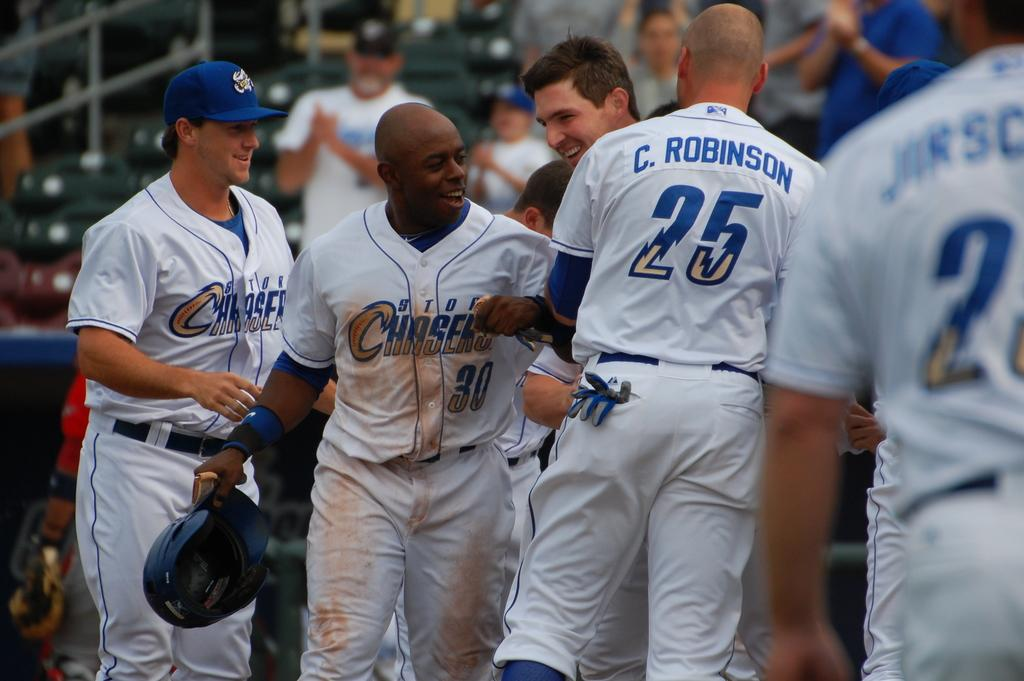<image>
Share a concise interpretation of the image provided. a jersey that has the number 25 on it 